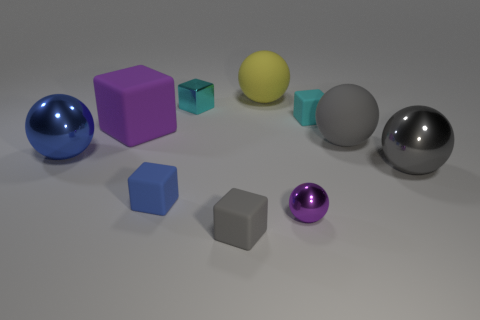Subtract 1 blocks. How many blocks are left? 4 Subtract all gray rubber spheres. How many spheres are left? 4 Subtract all purple cubes. How many cubes are left? 4 Subtract all green balls. Subtract all yellow cubes. How many balls are left? 5 Add 7 small red shiny blocks. How many small red shiny blocks exist? 7 Subtract 0 green spheres. How many objects are left? 10 Subtract all large yellow matte cylinders. Subtract all blue spheres. How many objects are left? 9 Add 4 tiny gray blocks. How many tiny gray blocks are left? 5 